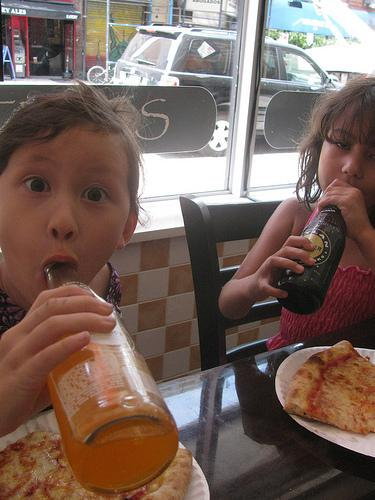Question: where is the picture taken?
Choices:
A. On the back of a truck.
B. In a meadow.
C. From a bridge.
D. Inside of a pizza joint.
Answer with the letter. Answer: D Question: how many children?
Choices:
A. 1.
B. 3.
C. 4.
D. 2.
Answer with the letter. Answer: D Question: what is the color of the table?
Choices:
A. Brown.
B. White.
C. Beige.
D. Black.
Answer with the letter. Answer: D Question: what is in the plate?
Choices:
A. Chicken.
B. Steak.
C. Salad.
D. Pizza.
Answer with the letter. Answer: D Question: how is the day?
Choices:
A. Rainy.
B. Sunny.
C. Cloudy.
D. Snowy.
Answer with the letter. Answer: B 